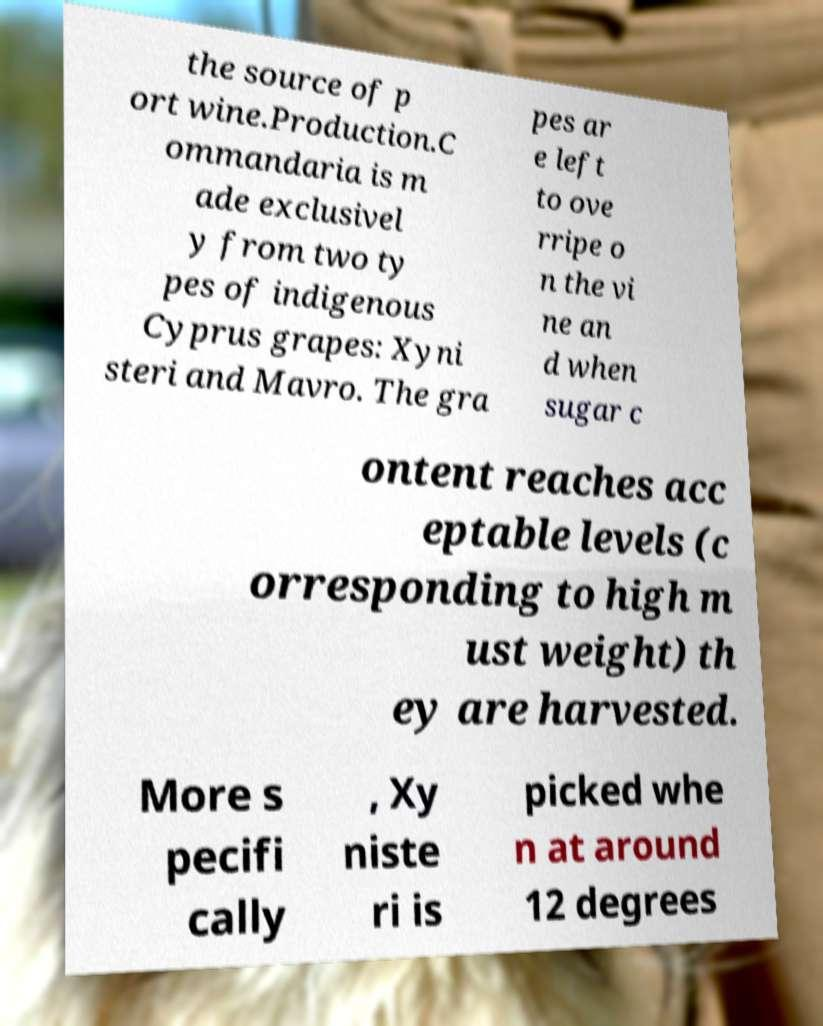Could you assist in decoding the text presented in this image and type it out clearly? the source of p ort wine.Production.C ommandaria is m ade exclusivel y from two ty pes of indigenous Cyprus grapes: Xyni steri and Mavro. The gra pes ar e left to ove rripe o n the vi ne an d when sugar c ontent reaches acc eptable levels (c orresponding to high m ust weight) th ey are harvested. More s pecifi cally , Xy niste ri is picked whe n at around 12 degrees 